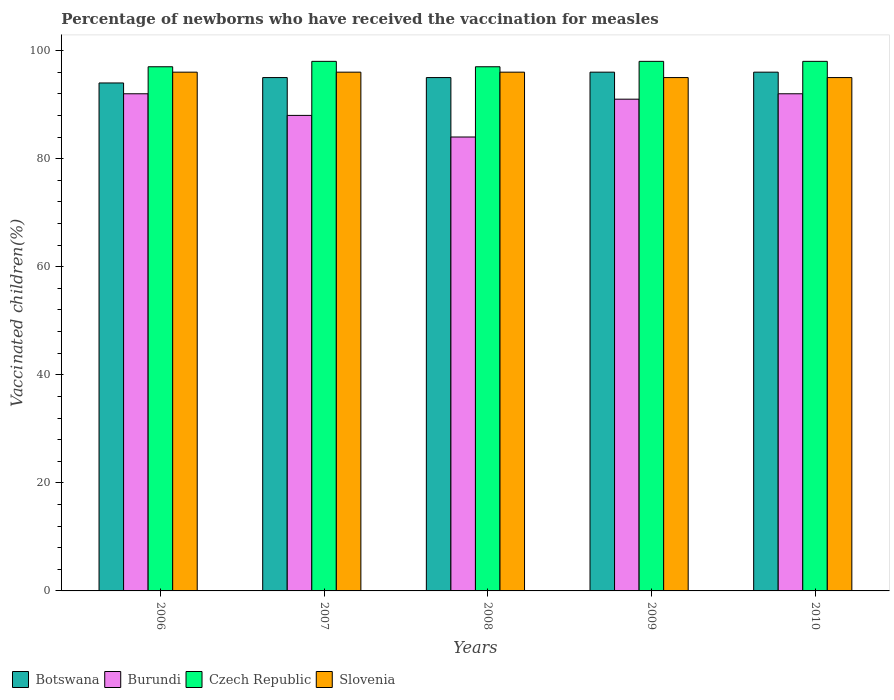How many different coloured bars are there?
Keep it short and to the point. 4. Are the number of bars on each tick of the X-axis equal?
Provide a succinct answer. Yes. How many bars are there on the 4th tick from the left?
Offer a very short reply. 4. What is the label of the 3rd group of bars from the left?
Your answer should be compact. 2008. In how many cases, is the number of bars for a given year not equal to the number of legend labels?
Your response must be concise. 0. What is the percentage of vaccinated children in Slovenia in 2009?
Your answer should be very brief. 95. Across all years, what is the maximum percentage of vaccinated children in Botswana?
Provide a succinct answer. 96. Across all years, what is the minimum percentage of vaccinated children in Botswana?
Your answer should be compact. 94. In which year was the percentage of vaccinated children in Slovenia maximum?
Make the answer very short. 2006. What is the total percentage of vaccinated children in Slovenia in the graph?
Provide a short and direct response. 478. What is the difference between the percentage of vaccinated children in Botswana in 2009 and that in 2010?
Provide a short and direct response. 0. What is the average percentage of vaccinated children in Slovenia per year?
Make the answer very short. 95.6. In the year 2006, what is the difference between the percentage of vaccinated children in Czech Republic and percentage of vaccinated children in Burundi?
Give a very brief answer. 5. What is the ratio of the percentage of vaccinated children in Czech Republic in 2006 to that in 2007?
Ensure brevity in your answer.  0.99. Is the difference between the percentage of vaccinated children in Czech Republic in 2009 and 2010 greater than the difference between the percentage of vaccinated children in Burundi in 2009 and 2010?
Offer a terse response. Yes. What is the difference between the highest and the lowest percentage of vaccinated children in Botswana?
Keep it short and to the point. 2. In how many years, is the percentage of vaccinated children in Czech Republic greater than the average percentage of vaccinated children in Czech Republic taken over all years?
Your answer should be compact. 3. What does the 4th bar from the left in 2007 represents?
Give a very brief answer. Slovenia. What does the 2nd bar from the right in 2006 represents?
Ensure brevity in your answer.  Czech Republic. What is the difference between two consecutive major ticks on the Y-axis?
Provide a succinct answer. 20. Does the graph contain grids?
Offer a terse response. No. How many legend labels are there?
Provide a short and direct response. 4. How are the legend labels stacked?
Your answer should be very brief. Horizontal. What is the title of the graph?
Offer a terse response. Percentage of newborns who have received the vaccination for measles. Does "Vietnam" appear as one of the legend labels in the graph?
Offer a very short reply. No. What is the label or title of the Y-axis?
Your response must be concise. Vaccinated children(%). What is the Vaccinated children(%) of Botswana in 2006?
Provide a short and direct response. 94. What is the Vaccinated children(%) of Burundi in 2006?
Your answer should be compact. 92. What is the Vaccinated children(%) in Czech Republic in 2006?
Make the answer very short. 97. What is the Vaccinated children(%) in Slovenia in 2006?
Your answer should be compact. 96. What is the Vaccinated children(%) of Botswana in 2007?
Offer a very short reply. 95. What is the Vaccinated children(%) in Burundi in 2007?
Ensure brevity in your answer.  88. What is the Vaccinated children(%) in Slovenia in 2007?
Give a very brief answer. 96. What is the Vaccinated children(%) in Botswana in 2008?
Your response must be concise. 95. What is the Vaccinated children(%) of Czech Republic in 2008?
Your response must be concise. 97. What is the Vaccinated children(%) of Slovenia in 2008?
Offer a terse response. 96. What is the Vaccinated children(%) in Botswana in 2009?
Offer a terse response. 96. What is the Vaccinated children(%) in Burundi in 2009?
Offer a very short reply. 91. What is the Vaccinated children(%) in Botswana in 2010?
Make the answer very short. 96. What is the Vaccinated children(%) of Burundi in 2010?
Provide a short and direct response. 92. What is the Vaccinated children(%) of Slovenia in 2010?
Offer a very short reply. 95. Across all years, what is the maximum Vaccinated children(%) in Botswana?
Make the answer very short. 96. Across all years, what is the maximum Vaccinated children(%) of Burundi?
Your response must be concise. 92. Across all years, what is the maximum Vaccinated children(%) of Slovenia?
Provide a short and direct response. 96. Across all years, what is the minimum Vaccinated children(%) in Botswana?
Keep it short and to the point. 94. Across all years, what is the minimum Vaccinated children(%) of Burundi?
Keep it short and to the point. 84. Across all years, what is the minimum Vaccinated children(%) in Czech Republic?
Give a very brief answer. 97. What is the total Vaccinated children(%) of Botswana in the graph?
Ensure brevity in your answer.  476. What is the total Vaccinated children(%) in Burundi in the graph?
Keep it short and to the point. 447. What is the total Vaccinated children(%) of Czech Republic in the graph?
Offer a terse response. 488. What is the total Vaccinated children(%) of Slovenia in the graph?
Your answer should be very brief. 478. What is the difference between the Vaccinated children(%) in Czech Republic in 2006 and that in 2007?
Provide a succinct answer. -1. What is the difference between the Vaccinated children(%) in Slovenia in 2006 and that in 2007?
Ensure brevity in your answer.  0. What is the difference between the Vaccinated children(%) of Burundi in 2006 and that in 2008?
Provide a succinct answer. 8. What is the difference between the Vaccinated children(%) of Czech Republic in 2006 and that in 2008?
Keep it short and to the point. 0. What is the difference between the Vaccinated children(%) of Slovenia in 2006 and that in 2008?
Give a very brief answer. 0. What is the difference between the Vaccinated children(%) of Botswana in 2006 and that in 2009?
Your answer should be compact. -2. What is the difference between the Vaccinated children(%) in Czech Republic in 2006 and that in 2009?
Give a very brief answer. -1. What is the difference between the Vaccinated children(%) of Botswana in 2006 and that in 2010?
Keep it short and to the point. -2. What is the difference between the Vaccinated children(%) of Czech Republic in 2006 and that in 2010?
Provide a short and direct response. -1. What is the difference between the Vaccinated children(%) in Botswana in 2007 and that in 2008?
Provide a short and direct response. 0. What is the difference between the Vaccinated children(%) of Czech Republic in 2007 and that in 2008?
Offer a very short reply. 1. What is the difference between the Vaccinated children(%) in Botswana in 2007 and that in 2009?
Make the answer very short. -1. What is the difference between the Vaccinated children(%) in Burundi in 2007 and that in 2009?
Offer a terse response. -3. What is the difference between the Vaccinated children(%) in Botswana in 2007 and that in 2010?
Your answer should be compact. -1. What is the difference between the Vaccinated children(%) in Slovenia in 2007 and that in 2010?
Provide a short and direct response. 1. What is the difference between the Vaccinated children(%) of Botswana in 2008 and that in 2009?
Your answer should be very brief. -1. What is the difference between the Vaccinated children(%) of Burundi in 2008 and that in 2009?
Give a very brief answer. -7. What is the difference between the Vaccinated children(%) of Czech Republic in 2008 and that in 2010?
Make the answer very short. -1. What is the difference between the Vaccinated children(%) in Botswana in 2009 and that in 2010?
Make the answer very short. 0. What is the difference between the Vaccinated children(%) of Burundi in 2009 and that in 2010?
Provide a succinct answer. -1. What is the difference between the Vaccinated children(%) of Slovenia in 2009 and that in 2010?
Give a very brief answer. 0. What is the difference between the Vaccinated children(%) of Botswana in 2006 and the Vaccinated children(%) of Burundi in 2007?
Offer a terse response. 6. What is the difference between the Vaccinated children(%) in Czech Republic in 2006 and the Vaccinated children(%) in Slovenia in 2007?
Give a very brief answer. 1. What is the difference between the Vaccinated children(%) in Botswana in 2006 and the Vaccinated children(%) in Burundi in 2008?
Your answer should be compact. 10. What is the difference between the Vaccinated children(%) of Botswana in 2006 and the Vaccinated children(%) of Czech Republic in 2008?
Provide a succinct answer. -3. What is the difference between the Vaccinated children(%) in Burundi in 2006 and the Vaccinated children(%) in Czech Republic in 2008?
Offer a terse response. -5. What is the difference between the Vaccinated children(%) in Burundi in 2006 and the Vaccinated children(%) in Slovenia in 2008?
Make the answer very short. -4. What is the difference between the Vaccinated children(%) of Botswana in 2006 and the Vaccinated children(%) of Czech Republic in 2009?
Make the answer very short. -4. What is the difference between the Vaccinated children(%) of Botswana in 2006 and the Vaccinated children(%) of Slovenia in 2009?
Make the answer very short. -1. What is the difference between the Vaccinated children(%) of Czech Republic in 2006 and the Vaccinated children(%) of Slovenia in 2009?
Your response must be concise. 2. What is the difference between the Vaccinated children(%) in Botswana in 2006 and the Vaccinated children(%) in Czech Republic in 2010?
Provide a short and direct response. -4. What is the difference between the Vaccinated children(%) in Burundi in 2006 and the Vaccinated children(%) in Slovenia in 2010?
Give a very brief answer. -3. What is the difference between the Vaccinated children(%) in Czech Republic in 2006 and the Vaccinated children(%) in Slovenia in 2010?
Provide a short and direct response. 2. What is the difference between the Vaccinated children(%) in Botswana in 2007 and the Vaccinated children(%) in Slovenia in 2008?
Give a very brief answer. -1. What is the difference between the Vaccinated children(%) in Burundi in 2007 and the Vaccinated children(%) in Czech Republic in 2008?
Ensure brevity in your answer.  -9. What is the difference between the Vaccinated children(%) in Burundi in 2007 and the Vaccinated children(%) in Slovenia in 2008?
Provide a succinct answer. -8. What is the difference between the Vaccinated children(%) in Botswana in 2007 and the Vaccinated children(%) in Burundi in 2009?
Offer a terse response. 4. What is the difference between the Vaccinated children(%) of Botswana in 2007 and the Vaccinated children(%) of Czech Republic in 2009?
Offer a terse response. -3. What is the difference between the Vaccinated children(%) in Burundi in 2007 and the Vaccinated children(%) in Czech Republic in 2009?
Keep it short and to the point. -10. What is the difference between the Vaccinated children(%) of Czech Republic in 2007 and the Vaccinated children(%) of Slovenia in 2009?
Give a very brief answer. 3. What is the difference between the Vaccinated children(%) in Burundi in 2007 and the Vaccinated children(%) in Czech Republic in 2010?
Your answer should be compact. -10. What is the difference between the Vaccinated children(%) of Botswana in 2008 and the Vaccinated children(%) of Burundi in 2009?
Keep it short and to the point. 4. What is the difference between the Vaccinated children(%) of Botswana in 2008 and the Vaccinated children(%) of Slovenia in 2009?
Provide a succinct answer. 0. What is the difference between the Vaccinated children(%) of Burundi in 2008 and the Vaccinated children(%) of Czech Republic in 2009?
Your response must be concise. -14. What is the difference between the Vaccinated children(%) in Burundi in 2008 and the Vaccinated children(%) in Slovenia in 2009?
Provide a short and direct response. -11. What is the difference between the Vaccinated children(%) of Czech Republic in 2008 and the Vaccinated children(%) of Slovenia in 2009?
Provide a short and direct response. 2. What is the difference between the Vaccinated children(%) in Botswana in 2008 and the Vaccinated children(%) in Burundi in 2010?
Your response must be concise. 3. What is the difference between the Vaccinated children(%) of Botswana in 2008 and the Vaccinated children(%) of Slovenia in 2010?
Offer a very short reply. 0. What is the difference between the Vaccinated children(%) in Burundi in 2008 and the Vaccinated children(%) in Czech Republic in 2010?
Offer a very short reply. -14. What is the difference between the Vaccinated children(%) of Burundi in 2008 and the Vaccinated children(%) of Slovenia in 2010?
Ensure brevity in your answer.  -11. What is the difference between the Vaccinated children(%) in Czech Republic in 2008 and the Vaccinated children(%) in Slovenia in 2010?
Provide a short and direct response. 2. What is the difference between the Vaccinated children(%) in Botswana in 2009 and the Vaccinated children(%) in Burundi in 2010?
Offer a terse response. 4. What is the difference between the Vaccinated children(%) in Botswana in 2009 and the Vaccinated children(%) in Czech Republic in 2010?
Offer a terse response. -2. What is the difference between the Vaccinated children(%) in Botswana in 2009 and the Vaccinated children(%) in Slovenia in 2010?
Offer a terse response. 1. What is the difference between the Vaccinated children(%) in Burundi in 2009 and the Vaccinated children(%) in Czech Republic in 2010?
Your response must be concise. -7. What is the difference between the Vaccinated children(%) of Czech Republic in 2009 and the Vaccinated children(%) of Slovenia in 2010?
Your answer should be compact. 3. What is the average Vaccinated children(%) in Botswana per year?
Your response must be concise. 95.2. What is the average Vaccinated children(%) in Burundi per year?
Your response must be concise. 89.4. What is the average Vaccinated children(%) of Czech Republic per year?
Ensure brevity in your answer.  97.6. What is the average Vaccinated children(%) in Slovenia per year?
Your answer should be very brief. 95.6. In the year 2006, what is the difference between the Vaccinated children(%) of Botswana and Vaccinated children(%) of Burundi?
Offer a very short reply. 2. In the year 2006, what is the difference between the Vaccinated children(%) of Botswana and Vaccinated children(%) of Slovenia?
Ensure brevity in your answer.  -2. In the year 2006, what is the difference between the Vaccinated children(%) in Czech Republic and Vaccinated children(%) in Slovenia?
Offer a terse response. 1. In the year 2007, what is the difference between the Vaccinated children(%) in Botswana and Vaccinated children(%) in Burundi?
Your answer should be compact. 7. In the year 2007, what is the difference between the Vaccinated children(%) of Botswana and Vaccinated children(%) of Czech Republic?
Provide a succinct answer. -3. In the year 2007, what is the difference between the Vaccinated children(%) of Burundi and Vaccinated children(%) of Czech Republic?
Your answer should be very brief. -10. In the year 2007, what is the difference between the Vaccinated children(%) in Burundi and Vaccinated children(%) in Slovenia?
Offer a terse response. -8. In the year 2007, what is the difference between the Vaccinated children(%) of Czech Republic and Vaccinated children(%) of Slovenia?
Your response must be concise. 2. In the year 2008, what is the difference between the Vaccinated children(%) of Botswana and Vaccinated children(%) of Burundi?
Make the answer very short. 11. In the year 2008, what is the difference between the Vaccinated children(%) of Botswana and Vaccinated children(%) of Slovenia?
Provide a succinct answer. -1. In the year 2008, what is the difference between the Vaccinated children(%) in Czech Republic and Vaccinated children(%) in Slovenia?
Your answer should be compact. 1. In the year 2009, what is the difference between the Vaccinated children(%) of Botswana and Vaccinated children(%) of Burundi?
Provide a short and direct response. 5. In the year 2009, what is the difference between the Vaccinated children(%) of Botswana and Vaccinated children(%) of Slovenia?
Offer a very short reply. 1. In the year 2010, what is the difference between the Vaccinated children(%) of Botswana and Vaccinated children(%) of Burundi?
Offer a terse response. 4. In the year 2010, what is the difference between the Vaccinated children(%) of Botswana and Vaccinated children(%) of Slovenia?
Keep it short and to the point. 1. In the year 2010, what is the difference between the Vaccinated children(%) in Czech Republic and Vaccinated children(%) in Slovenia?
Your response must be concise. 3. What is the ratio of the Vaccinated children(%) of Botswana in 2006 to that in 2007?
Provide a short and direct response. 0.99. What is the ratio of the Vaccinated children(%) of Burundi in 2006 to that in 2007?
Your answer should be compact. 1.05. What is the ratio of the Vaccinated children(%) in Czech Republic in 2006 to that in 2007?
Make the answer very short. 0.99. What is the ratio of the Vaccinated children(%) in Slovenia in 2006 to that in 2007?
Make the answer very short. 1. What is the ratio of the Vaccinated children(%) of Botswana in 2006 to that in 2008?
Ensure brevity in your answer.  0.99. What is the ratio of the Vaccinated children(%) in Burundi in 2006 to that in 2008?
Your answer should be compact. 1.1. What is the ratio of the Vaccinated children(%) in Slovenia in 2006 to that in 2008?
Offer a terse response. 1. What is the ratio of the Vaccinated children(%) of Botswana in 2006 to that in 2009?
Offer a terse response. 0.98. What is the ratio of the Vaccinated children(%) in Burundi in 2006 to that in 2009?
Ensure brevity in your answer.  1.01. What is the ratio of the Vaccinated children(%) of Slovenia in 2006 to that in 2009?
Make the answer very short. 1.01. What is the ratio of the Vaccinated children(%) in Botswana in 2006 to that in 2010?
Give a very brief answer. 0.98. What is the ratio of the Vaccinated children(%) of Slovenia in 2006 to that in 2010?
Offer a terse response. 1.01. What is the ratio of the Vaccinated children(%) in Botswana in 2007 to that in 2008?
Provide a succinct answer. 1. What is the ratio of the Vaccinated children(%) of Burundi in 2007 to that in 2008?
Provide a succinct answer. 1.05. What is the ratio of the Vaccinated children(%) of Czech Republic in 2007 to that in 2008?
Your answer should be very brief. 1.01. What is the ratio of the Vaccinated children(%) of Burundi in 2007 to that in 2009?
Keep it short and to the point. 0.97. What is the ratio of the Vaccinated children(%) of Slovenia in 2007 to that in 2009?
Offer a terse response. 1.01. What is the ratio of the Vaccinated children(%) of Botswana in 2007 to that in 2010?
Offer a very short reply. 0.99. What is the ratio of the Vaccinated children(%) of Burundi in 2007 to that in 2010?
Offer a terse response. 0.96. What is the ratio of the Vaccinated children(%) of Slovenia in 2007 to that in 2010?
Make the answer very short. 1.01. What is the ratio of the Vaccinated children(%) in Czech Republic in 2008 to that in 2009?
Offer a very short reply. 0.99. What is the ratio of the Vaccinated children(%) of Slovenia in 2008 to that in 2009?
Your response must be concise. 1.01. What is the ratio of the Vaccinated children(%) of Slovenia in 2008 to that in 2010?
Provide a succinct answer. 1.01. What is the ratio of the Vaccinated children(%) in Botswana in 2009 to that in 2010?
Keep it short and to the point. 1. What is the ratio of the Vaccinated children(%) in Czech Republic in 2009 to that in 2010?
Your response must be concise. 1. What is the difference between the highest and the second highest Vaccinated children(%) in Burundi?
Your answer should be compact. 0. What is the difference between the highest and the second highest Vaccinated children(%) in Czech Republic?
Offer a very short reply. 0. What is the difference between the highest and the lowest Vaccinated children(%) of Botswana?
Provide a short and direct response. 2. What is the difference between the highest and the lowest Vaccinated children(%) of Slovenia?
Ensure brevity in your answer.  1. 